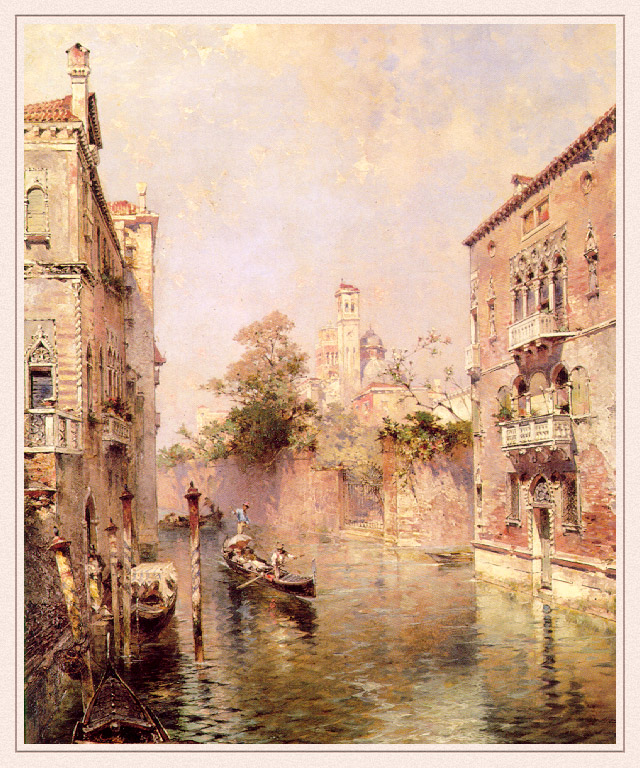Can you provide some historical context about the scene depicted in this image? Venice, historically known as 'La Serenissima,' is portrayed in this image, showcasing its renowned canals. Historically, Venice emerged as a major maritime power during the Middle Ages and the Renaissance. The city's strategic location on the Adriatic Sea made it a crucial center for trade between Europe and the Byzantine Empire, as well as the Islamic world. The buildings flanking the canal reflect the Venetian Gothic style, which flourished during the 14th century, characterized by pointed arches and elaborate facades. The gondola, a traditional Venetian boat, has been a popular mode of transport in Venice since the 11th century. This scene likely captures the essence of daily life in a bygone era, with the architecture and serene waterways evoking a timeless beauty that has endured through centuries. What emotions does the artist convey through this painting? The artist conveys a sense of peace, tranquility, and nostalgia through the painting. The soft color palette of pastel hues combined with the gentle reflections on the canal water creates a calming atmosphere. The depiction of the gondola smoothly gliding along the canal suggests a slow and leisurely pace of life, evoking a longing for a simpler, more serene existence. The ornate buildings contribute to the nostalgic mood by capturing the splendor of Venice's historical architecture, alluding to a bygone era of grandeur and elegance. 